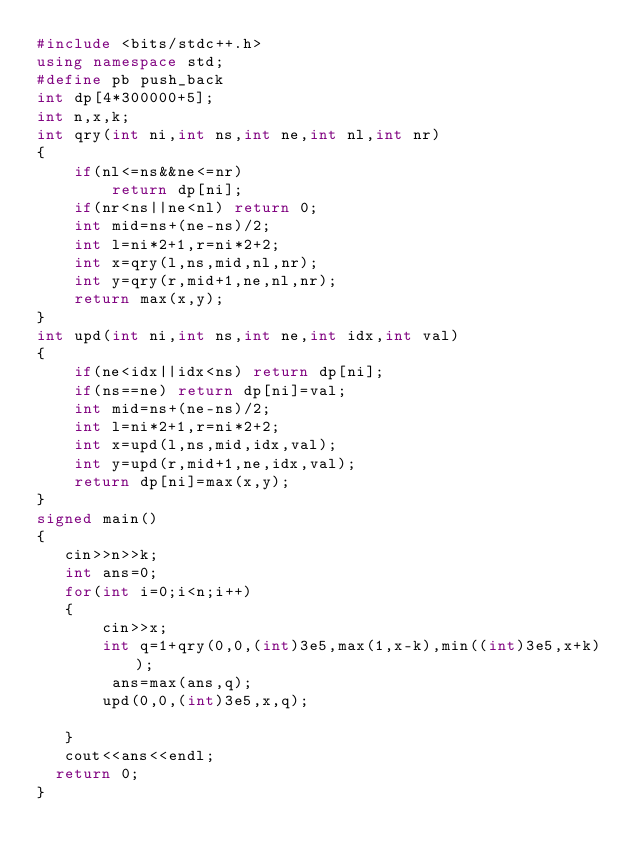<code> <loc_0><loc_0><loc_500><loc_500><_C++_>#include <bits/stdc++.h>
using namespace std;
#define pb push_back
int dp[4*300000+5];
int n,x,k;
int qry(int ni,int ns,int ne,int nl,int nr)
{
    if(nl<=ns&&ne<=nr)
        return dp[ni];
    if(nr<ns||ne<nl) return 0;
    int mid=ns+(ne-ns)/2;
    int l=ni*2+1,r=ni*2+2;
    int x=qry(l,ns,mid,nl,nr);
    int y=qry(r,mid+1,ne,nl,nr);
    return max(x,y);
}
int upd(int ni,int ns,int ne,int idx,int val)
{
    if(ne<idx||idx<ns) return dp[ni];
    if(ns==ne) return dp[ni]=val;
    int mid=ns+(ne-ns)/2;
    int l=ni*2+1,r=ni*2+2;
    int x=upd(l,ns,mid,idx,val);
    int y=upd(r,mid+1,ne,idx,val);
    return dp[ni]=max(x,y);
}
signed main()
{
   cin>>n>>k;
   int ans=0;
   for(int i=0;i<n;i++)
   {
       cin>>x;
       int q=1+qry(0,0,(int)3e5,max(1,x-k),min((int)3e5,x+k));
        ans=max(ans,q);
       upd(0,0,(int)3e5,x,q);

   }
   cout<<ans<<endl;
	return 0;
}

</code> 